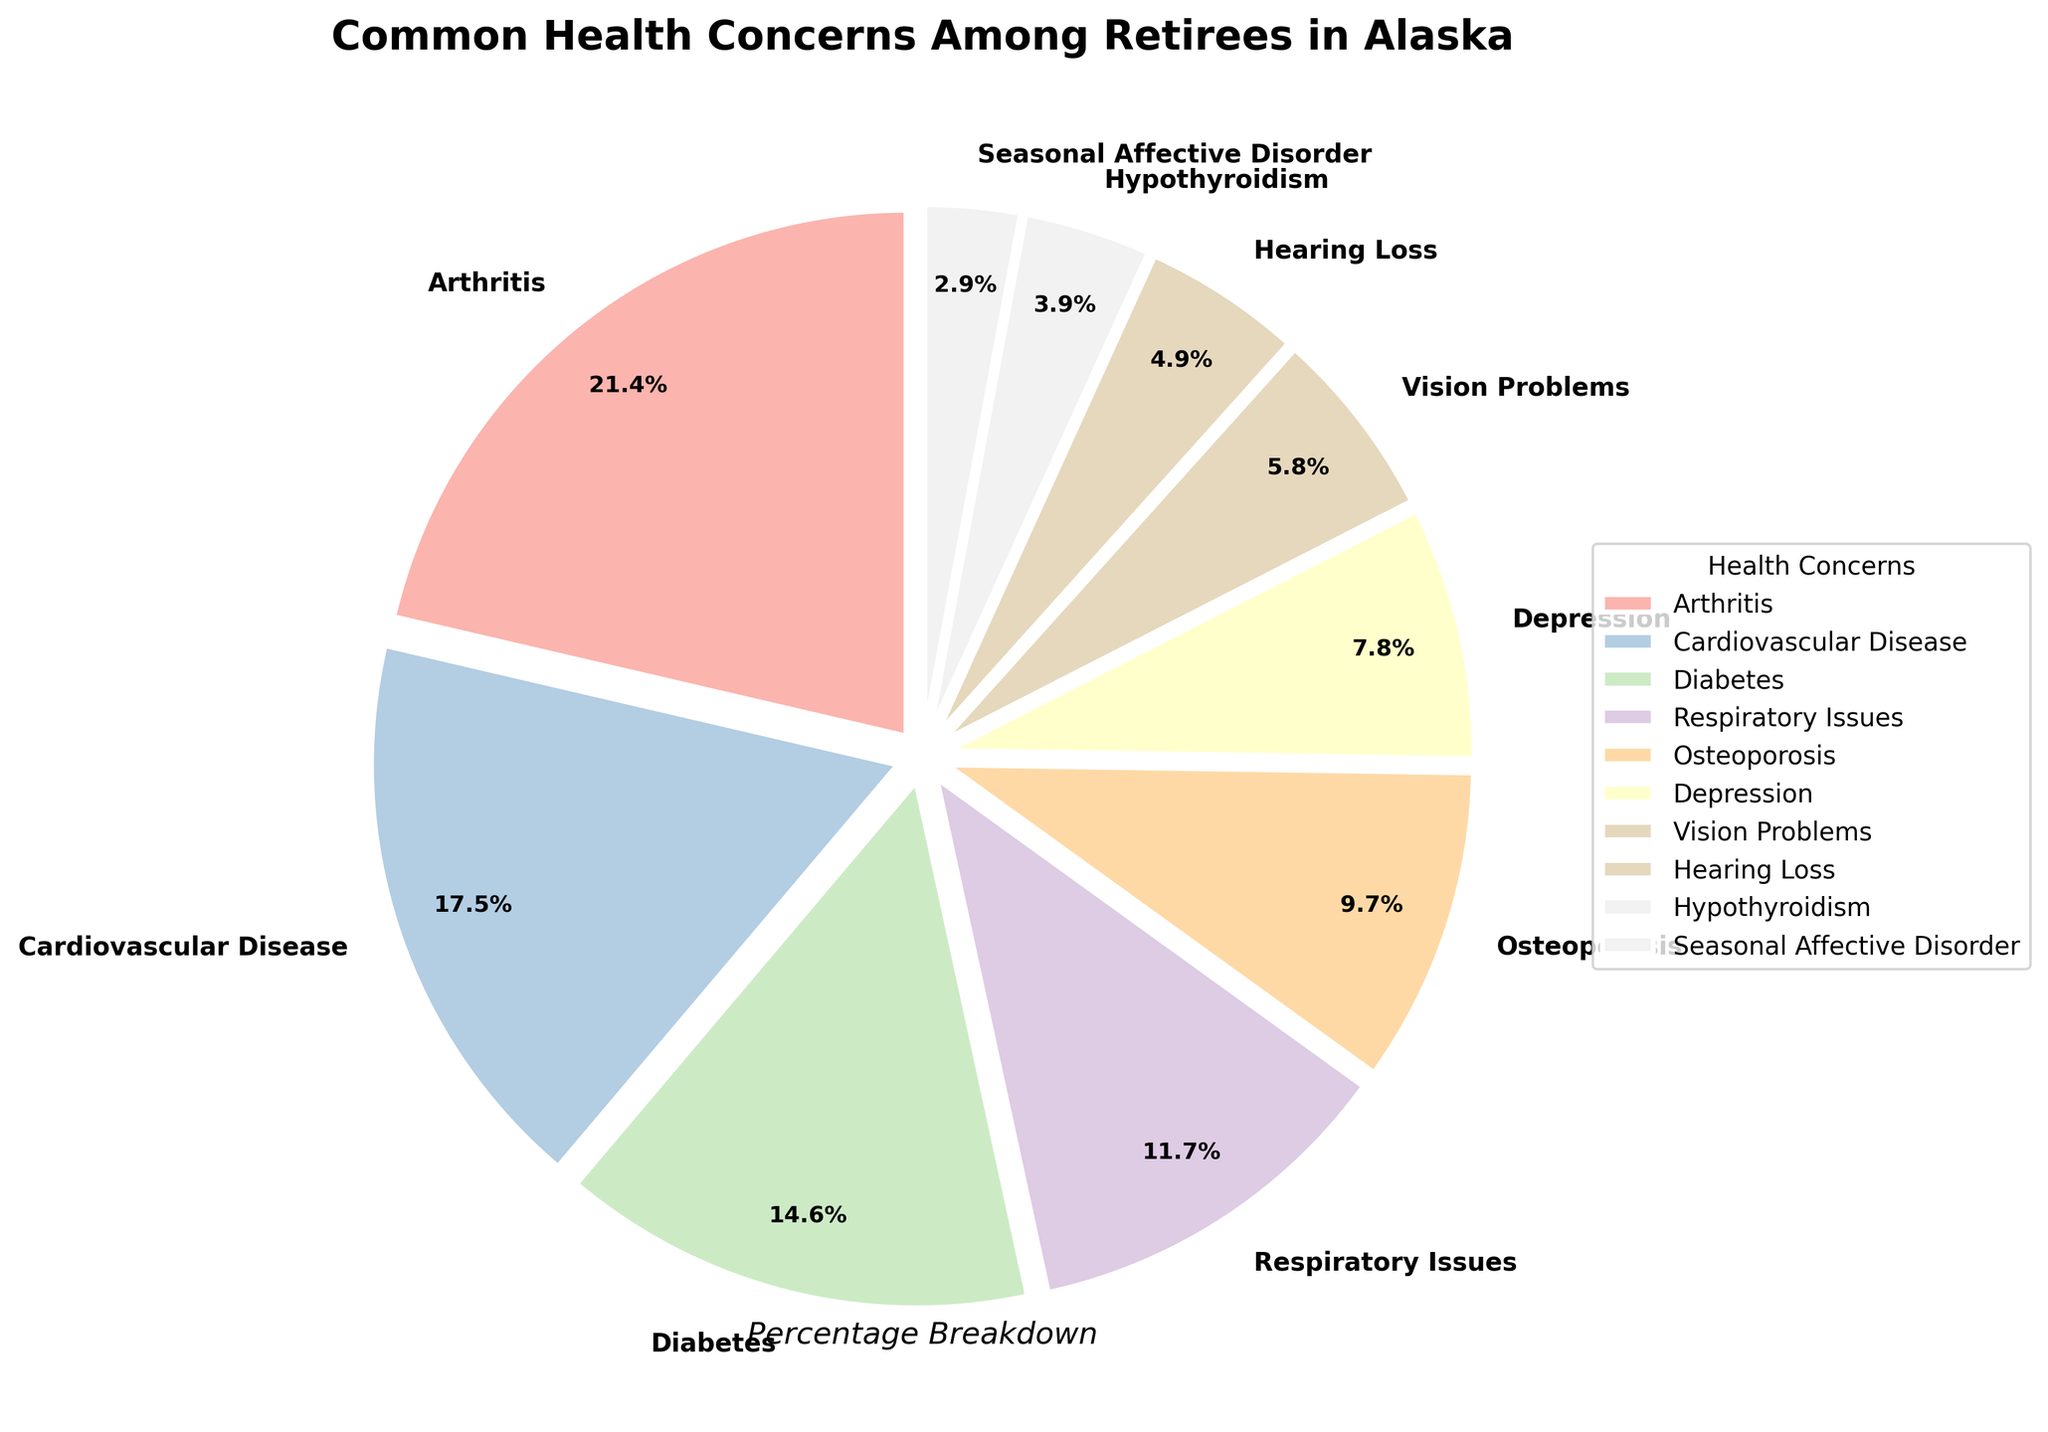What is the most common health concern among retirees in Alaska? Locate the largest wedge in the pie chart. The biggest section represents the most common health concern.
Answer: Arthritis What is the percentage of retirees affected by cardiovascular disease and diabetes combined? Find the percentage values for both cardiovascular disease (18%) and diabetes (15%). Add these percentages together: 18% + 15% = 33%.
Answer: 33% Are vision problems more common than respiratory issues among retirees? Compare the sizes of the wedges for vision problems (6%) and respiratory issues (12%). The wedge for respiratory issues is larger.
Answer: No Between depression and osteoporosis, which health concern has a higher percentage among retirees? Compare the wedges for depression (8%) and osteoporosis (10%). The wedge for osteoporosis is larger.
Answer: Osteoporosis What is the total percentage of health concerns that have a percentage less than diabetes? Identify sections with percentages less than 15% (respiratory issues, osteoporosis, depression, vision problems, hearing loss, hypothyroidism, seasonal affective disorder). Add their percentages: 12% + 10% + 8% + 6% + 5% + 4% +3% = 48%.
Answer: 48% Which health concern is the least common among retirees in Alaska? Locate the smallest wedge in the pie chart. The smallest section represents the least common health concern.
Answer: Seasonal Affective Disorder How much larger is the percentage of retirees with arthritis compared to those with respiratory issues? Subtract the percentage for respiratory issues (12%) from the percentage for arthritis (22%): 22% - 12% = 10%.
Answer: 10% What is the difference in percentage between hearing loss and hypothyroidism among retirees? Subtract the percentage for hypothyroidism (4%) from the percentage for hearing loss (5%): 5% - 4% = 1%.
Answer: 1% Which health concerns have a combined percentage of 30%? Look for wedges that add up to 30%. Diabetes (15%), respiratory issues (12%), and hypothyroidism (3%) together add up to 30%.
Answer: Diabetes, Respiratory Issues, Hypothyroidism 